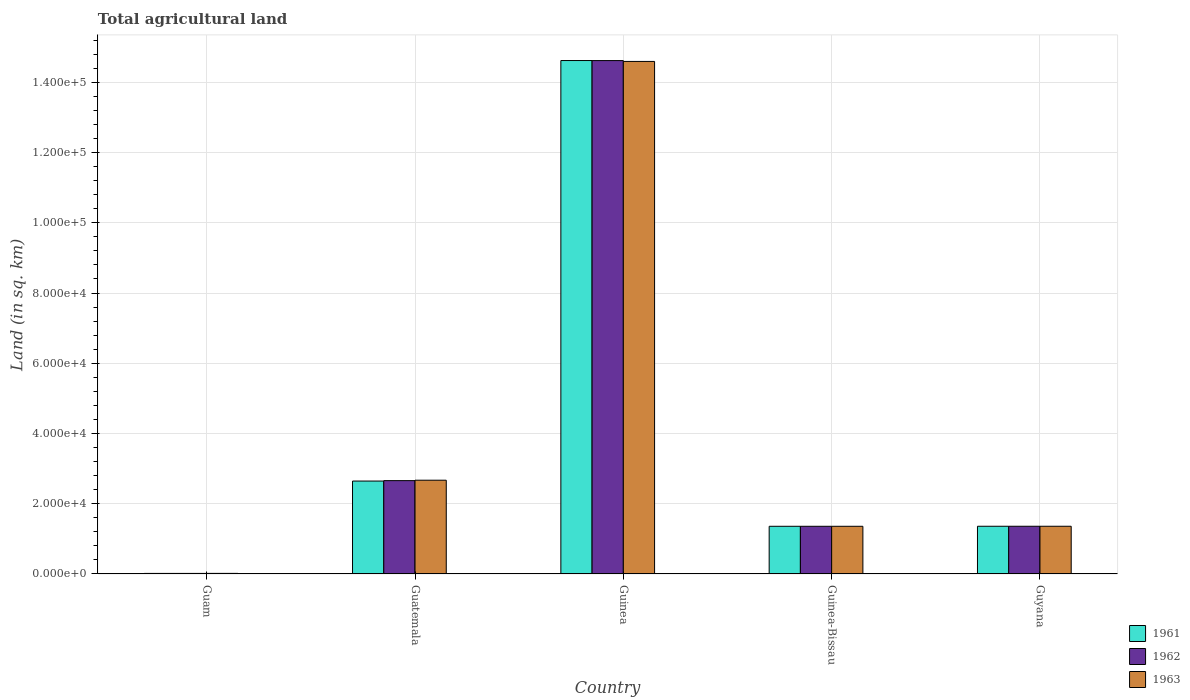Are the number of bars per tick equal to the number of legend labels?
Your response must be concise. Yes. How many bars are there on the 4th tick from the right?
Give a very brief answer. 3. What is the label of the 2nd group of bars from the left?
Make the answer very short. Guatemala. What is the total agricultural land in 1961 in Guinea-Bissau?
Your answer should be very brief. 1.36e+04. Across all countries, what is the maximum total agricultural land in 1962?
Make the answer very short. 1.46e+05. Across all countries, what is the minimum total agricultural land in 1963?
Keep it short and to the point. 170. In which country was the total agricultural land in 1962 maximum?
Your response must be concise. Guinea. In which country was the total agricultural land in 1961 minimum?
Make the answer very short. Guam. What is the total total agricultural land in 1962 in the graph?
Keep it short and to the point. 2.00e+05. What is the difference between the total agricultural land in 1962 in Guatemala and that in Guinea?
Give a very brief answer. -1.20e+05. What is the difference between the total agricultural land in 1961 in Guinea and the total agricultural land in 1963 in Guam?
Offer a terse response. 1.46e+05. What is the average total agricultural land in 1963 per country?
Ensure brevity in your answer.  4.00e+04. What is the difference between the total agricultural land of/in 1963 and total agricultural land of/in 1961 in Guyana?
Provide a short and direct response. 0. What is the ratio of the total agricultural land in 1962 in Guinea to that in Guyana?
Give a very brief answer. 10.76. Is the total agricultural land in 1963 in Guinea less than that in Guyana?
Offer a very short reply. No. Is the difference between the total agricultural land in 1963 in Guinea and Guyana greater than the difference between the total agricultural land in 1961 in Guinea and Guyana?
Your response must be concise. No. What is the difference between the highest and the second highest total agricultural land in 1963?
Offer a very short reply. -1.19e+05. What is the difference between the highest and the lowest total agricultural land in 1963?
Keep it short and to the point. 1.46e+05. Is the sum of the total agricultural land in 1961 in Guatemala and Guyana greater than the maximum total agricultural land in 1963 across all countries?
Your answer should be very brief. No. Is it the case that in every country, the sum of the total agricultural land in 1961 and total agricultural land in 1962 is greater than the total agricultural land in 1963?
Keep it short and to the point. Yes. How many bars are there?
Keep it short and to the point. 15. Does the graph contain grids?
Keep it short and to the point. Yes. How are the legend labels stacked?
Make the answer very short. Vertical. What is the title of the graph?
Your answer should be very brief. Total agricultural land. What is the label or title of the X-axis?
Keep it short and to the point. Country. What is the label or title of the Y-axis?
Your response must be concise. Land (in sq. km). What is the Land (in sq. km) of 1961 in Guam?
Keep it short and to the point. 160. What is the Land (in sq. km) of 1962 in Guam?
Give a very brief answer. 160. What is the Land (in sq. km) of 1963 in Guam?
Your answer should be very brief. 170. What is the Land (in sq. km) in 1961 in Guatemala?
Offer a very short reply. 2.65e+04. What is the Land (in sq. km) in 1962 in Guatemala?
Your answer should be compact. 2.66e+04. What is the Land (in sq. km) of 1963 in Guatemala?
Make the answer very short. 2.67e+04. What is the Land (in sq. km) in 1961 in Guinea?
Your answer should be compact. 1.46e+05. What is the Land (in sq. km) of 1962 in Guinea?
Provide a succinct answer. 1.46e+05. What is the Land (in sq. km) of 1963 in Guinea?
Offer a terse response. 1.46e+05. What is the Land (in sq. km) of 1961 in Guinea-Bissau?
Your answer should be compact. 1.36e+04. What is the Land (in sq. km) of 1962 in Guinea-Bissau?
Ensure brevity in your answer.  1.36e+04. What is the Land (in sq. km) of 1963 in Guinea-Bissau?
Keep it short and to the point. 1.36e+04. What is the Land (in sq. km) in 1961 in Guyana?
Give a very brief answer. 1.36e+04. What is the Land (in sq. km) in 1962 in Guyana?
Offer a terse response. 1.36e+04. What is the Land (in sq. km) in 1963 in Guyana?
Offer a very short reply. 1.36e+04. Across all countries, what is the maximum Land (in sq. km) in 1961?
Give a very brief answer. 1.46e+05. Across all countries, what is the maximum Land (in sq. km) of 1962?
Your answer should be compact. 1.46e+05. Across all countries, what is the maximum Land (in sq. km) in 1963?
Make the answer very short. 1.46e+05. Across all countries, what is the minimum Land (in sq. km) in 1961?
Offer a terse response. 160. Across all countries, what is the minimum Land (in sq. km) of 1962?
Keep it short and to the point. 160. Across all countries, what is the minimum Land (in sq. km) of 1963?
Offer a terse response. 170. What is the total Land (in sq. km) in 1961 in the graph?
Your answer should be compact. 2.00e+05. What is the total Land (in sq. km) of 1962 in the graph?
Give a very brief answer. 2.00e+05. What is the total Land (in sq. km) of 1963 in the graph?
Offer a very short reply. 2.00e+05. What is the difference between the Land (in sq. km) of 1961 in Guam and that in Guatemala?
Your response must be concise. -2.63e+04. What is the difference between the Land (in sq. km) in 1962 in Guam and that in Guatemala?
Ensure brevity in your answer.  -2.64e+04. What is the difference between the Land (in sq. km) in 1963 in Guam and that in Guatemala?
Keep it short and to the point. -2.65e+04. What is the difference between the Land (in sq. km) in 1961 in Guam and that in Guinea?
Keep it short and to the point. -1.46e+05. What is the difference between the Land (in sq. km) of 1962 in Guam and that in Guinea?
Make the answer very short. -1.46e+05. What is the difference between the Land (in sq. km) of 1963 in Guam and that in Guinea?
Provide a short and direct response. -1.46e+05. What is the difference between the Land (in sq. km) in 1961 in Guam and that in Guinea-Bissau?
Your answer should be compact. -1.34e+04. What is the difference between the Land (in sq. km) in 1962 in Guam and that in Guinea-Bissau?
Ensure brevity in your answer.  -1.34e+04. What is the difference between the Land (in sq. km) of 1963 in Guam and that in Guinea-Bissau?
Keep it short and to the point. -1.34e+04. What is the difference between the Land (in sq. km) in 1961 in Guam and that in Guyana?
Provide a succinct answer. -1.34e+04. What is the difference between the Land (in sq. km) of 1962 in Guam and that in Guyana?
Ensure brevity in your answer.  -1.34e+04. What is the difference between the Land (in sq. km) of 1963 in Guam and that in Guyana?
Offer a terse response. -1.34e+04. What is the difference between the Land (in sq. km) in 1961 in Guatemala and that in Guinea?
Offer a very short reply. -1.20e+05. What is the difference between the Land (in sq. km) in 1962 in Guatemala and that in Guinea?
Make the answer very short. -1.20e+05. What is the difference between the Land (in sq. km) in 1963 in Guatemala and that in Guinea?
Offer a very short reply. -1.19e+05. What is the difference between the Land (in sq. km) of 1961 in Guatemala and that in Guinea-Bissau?
Ensure brevity in your answer.  1.29e+04. What is the difference between the Land (in sq. km) in 1962 in Guatemala and that in Guinea-Bissau?
Your response must be concise. 1.30e+04. What is the difference between the Land (in sq. km) in 1963 in Guatemala and that in Guinea-Bissau?
Your answer should be compact. 1.31e+04. What is the difference between the Land (in sq. km) in 1961 in Guatemala and that in Guyana?
Make the answer very short. 1.29e+04. What is the difference between the Land (in sq. km) in 1962 in Guatemala and that in Guyana?
Your answer should be compact. 1.30e+04. What is the difference between the Land (in sq. km) in 1963 in Guatemala and that in Guyana?
Offer a terse response. 1.31e+04. What is the difference between the Land (in sq. km) of 1961 in Guinea and that in Guinea-Bissau?
Your answer should be very brief. 1.33e+05. What is the difference between the Land (in sq. km) of 1962 in Guinea and that in Guinea-Bissau?
Ensure brevity in your answer.  1.33e+05. What is the difference between the Land (in sq. km) in 1963 in Guinea and that in Guinea-Bissau?
Your response must be concise. 1.32e+05. What is the difference between the Land (in sq. km) of 1961 in Guinea and that in Guyana?
Ensure brevity in your answer.  1.33e+05. What is the difference between the Land (in sq. km) of 1962 in Guinea and that in Guyana?
Your answer should be compact. 1.33e+05. What is the difference between the Land (in sq. km) of 1963 in Guinea and that in Guyana?
Your response must be concise. 1.32e+05. What is the difference between the Land (in sq. km) in 1962 in Guinea-Bissau and that in Guyana?
Ensure brevity in your answer.  -10. What is the difference between the Land (in sq. km) in 1961 in Guam and the Land (in sq. km) in 1962 in Guatemala?
Ensure brevity in your answer.  -2.64e+04. What is the difference between the Land (in sq. km) in 1961 in Guam and the Land (in sq. km) in 1963 in Guatemala?
Offer a terse response. -2.65e+04. What is the difference between the Land (in sq. km) in 1962 in Guam and the Land (in sq. km) in 1963 in Guatemala?
Provide a short and direct response. -2.65e+04. What is the difference between the Land (in sq. km) of 1961 in Guam and the Land (in sq. km) of 1962 in Guinea?
Your answer should be very brief. -1.46e+05. What is the difference between the Land (in sq. km) in 1961 in Guam and the Land (in sq. km) in 1963 in Guinea?
Your response must be concise. -1.46e+05. What is the difference between the Land (in sq. km) in 1962 in Guam and the Land (in sq. km) in 1963 in Guinea?
Ensure brevity in your answer.  -1.46e+05. What is the difference between the Land (in sq. km) of 1961 in Guam and the Land (in sq. km) of 1962 in Guinea-Bissau?
Ensure brevity in your answer.  -1.34e+04. What is the difference between the Land (in sq. km) in 1961 in Guam and the Land (in sq. km) in 1963 in Guinea-Bissau?
Make the answer very short. -1.34e+04. What is the difference between the Land (in sq. km) in 1962 in Guam and the Land (in sq. km) in 1963 in Guinea-Bissau?
Provide a short and direct response. -1.34e+04. What is the difference between the Land (in sq. km) of 1961 in Guam and the Land (in sq. km) of 1962 in Guyana?
Your answer should be compact. -1.34e+04. What is the difference between the Land (in sq. km) in 1961 in Guam and the Land (in sq. km) in 1963 in Guyana?
Give a very brief answer. -1.34e+04. What is the difference between the Land (in sq. km) in 1962 in Guam and the Land (in sq. km) in 1963 in Guyana?
Your answer should be very brief. -1.34e+04. What is the difference between the Land (in sq. km) of 1961 in Guatemala and the Land (in sq. km) of 1962 in Guinea?
Offer a terse response. -1.20e+05. What is the difference between the Land (in sq. km) in 1961 in Guatemala and the Land (in sq. km) in 1963 in Guinea?
Offer a terse response. -1.19e+05. What is the difference between the Land (in sq. km) in 1962 in Guatemala and the Land (in sq. km) in 1963 in Guinea?
Offer a very short reply. -1.19e+05. What is the difference between the Land (in sq. km) in 1961 in Guatemala and the Land (in sq. km) in 1962 in Guinea-Bissau?
Give a very brief answer. 1.29e+04. What is the difference between the Land (in sq. km) in 1961 in Guatemala and the Land (in sq. km) in 1963 in Guinea-Bissau?
Give a very brief answer. 1.29e+04. What is the difference between the Land (in sq. km) of 1962 in Guatemala and the Land (in sq. km) of 1963 in Guinea-Bissau?
Offer a very short reply. 1.30e+04. What is the difference between the Land (in sq. km) of 1961 in Guatemala and the Land (in sq. km) of 1962 in Guyana?
Ensure brevity in your answer.  1.29e+04. What is the difference between the Land (in sq. km) of 1961 in Guatemala and the Land (in sq. km) of 1963 in Guyana?
Ensure brevity in your answer.  1.29e+04. What is the difference between the Land (in sq. km) in 1962 in Guatemala and the Land (in sq. km) in 1963 in Guyana?
Give a very brief answer. 1.30e+04. What is the difference between the Land (in sq. km) of 1961 in Guinea and the Land (in sq. km) of 1962 in Guinea-Bissau?
Provide a succinct answer. 1.33e+05. What is the difference between the Land (in sq. km) of 1961 in Guinea and the Land (in sq. km) of 1963 in Guinea-Bissau?
Provide a short and direct response. 1.33e+05. What is the difference between the Land (in sq. km) of 1962 in Guinea and the Land (in sq. km) of 1963 in Guinea-Bissau?
Provide a succinct answer. 1.33e+05. What is the difference between the Land (in sq. km) of 1961 in Guinea and the Land (in sq. km) of 1962 in Guyana?
Offer a very short reply. 1.33e+05. What is the difference between the Land (in sq. km) in 1961 in Guinea and the Land (in sq. km) in 1963 in Guyana?
Provide a short and direct response. 1.33e+05. What is the difference between the Land (in sq. km) of 1962 in Guinea and the Land (in sq. km) of 1963 in Guyana?
Your answer should be very brief. 1.33e+05. What is the difference between the Land (in sq. km) of 1961 in Guinea-Bissau and the Land (in sq. km) of 1962 in Guyana?
Ensure brevity in your answer.  -10. What is the difference between the Land (in sq. km) in 1961 in Guinea-Bissau and the Land (in sq. km) in 1963 in Guyana?
Your answer should be compact. -10. What is the average Land (in sq. km) of 1961 per country?
Your answer should be very brief. 4.00e+04. What is the average Land (in sq. km) in 1962 per country?
Your answer should be very brief. 4.00e+04. What is the average Land (in sq. km) in 1963 per country?
Offer a terse response. 4.00e+04. What is the difference between the Land (in sq. km) in 1961 and Land (in sq. km) in 1962 in Guam?
Keep it short and to the point. 0. What is the difference between the Land (in sq. km) in 1961 and Land (in sq. km) in 1963 in Guam?
Provide a succinct answer. -10. What is the difference between the Land (in sq. km) of 1962 and Land (in sq. km) of 1963 in Guam?
Provide a short and direct response. -10. What is the difference between the Land (in sq. km) of 1961 and Land (in sq. km) of 1962 in Guatemala?
Offer a terse response. -120. What is the difference between the Land (in sq. km) in 1961 and Land (in sq. km) in 1963 in Guatemala?
Your answer should be very brief. -240. What is the difference between the Land (in sq. km) in 1962 and Land (in sq. km) in 1963 in Guatemala?
Ensure brevity in your answer.  -120. What is the difference between the Land (in sq. km) in 1961 and Land (in sq. km) in 1962 in Guinea?
Offer a very short reply. 10. What is the difference between the Land (in sq. km) in 1961 and Land (in sq. km) in 1963 in Guinea?
Offer a very short reply. 250. What is the difference between the Land (in sq. km) in 1962 and Land (in sq. km) in 1963 in Guinea?
Give a very brief answer. 240. What is the difference between the Land (in sq. km) in 1961 and Land (in sq. km) in 1962 in Guyana?
Your response must be concise. 0. What is the difference between the Land (in sq. km) in 1961 and Land (in sq. km) in 1963 in Guyana?
Keep it short and to the point. 0. What is the ratio of the Land (in sq. km) in 1961 in Guam to that in Guatemala?
Your answer should be very brief. 0.01. What is the ratio of the Land (in sq. km) in 1962 in Guam to that in Guatemala?
Your response must be concise. 0.01. What is the ratio of the Land (in sq. km) of 1963 in Guam to that in Guatemala?
Your response must be concise. 0.01. What is the ratio of the Land (in sq. km) of 1961 in Guam to that in Guinea?
Provide a succinct answer. 0. What is the ratio of the Land (in sq. km) in 1962 in Guam to that in Guinea?
Offer a terse response. 0. What is the ratio of the Land (in sq. km) in 1963 in Guam to that in Guinea?
Provide a short and direct response. 0. What is the ratio of the Land (in sq. km) of 1961 in Guam to that in Guinea-Bissau?
Offer a very short reply. 0.01. What is the ratio of the Land (in sq. km) of 1962 in Guam to that in Guinea-Bissau?
Keep it short and to the point. 0.01. What is the ratio of the Land (in sq. km) of 1963 in Guam to that in Guinea-Bissau?
Keep it short and to the point. 0.01. What is the ratio of the Land (in sq. km) in 1961 in Guam to that in Guyana?
Offer a very short reply. 0.01. What is the ratio of the Land (in sq. km) in 1962 in Guam to that in Guyana?
Make the answer very short. 0.01. What is the ratio of the Land (in sq. km) of 1963 in Guam to that in Guyana?
Offer a very short reply. 0.01. What is the ratio of the Land (in sq. km) in 1961 in Guatemala to that in Guinea?
Your answer should be very brief. 0.18. What is the ratio of the Land (in sq. km) in 1962 in Guatemala to that in Guinea?
Your answer should be compact. 0.18. What is the ratio of the Land (in sq. km) in 1963 in Guatemala to that in Guinea?
Keep it short and to the point. 0.18. What is the ratio of the Land (in sq. km) of 1961 in Guatemala to that in Guinea-Bissau?
Your answer should be compact. 1.95. What is the ratio of the Land (in sq. km) of 1962 in Guatemala to that in Guinea-Bissau?
Offer a very short reply. 1.96. What is the ratio of the Land (in sq. km) of 1963 in Guatemala to that in Guinea-Bissau?
Your response must be concise. 1.97. What is the ratio of the Land (in sq. km) of 1961 in Guatemala to that in Guyana?
Keep it short and to the point. 1.95. What is the ratio of the Land (in sq. km) of 1962 in Guatemala to that in Guyana?
Give a very brief answer. 1.96. What is the ratio of the Land (in sq. km) in 1963 in Guatemala to that in Guyana?
Make the answer very short. 1.96. What is the ratio of the Land (in sq. km) of 1961 in Guinea to that in Guinea-Bissau?
Provide a succinct answer. 10.77. What is the ratio of the Land (in sq. km) of 1962 in Guinea to that in Guinea-Bissau?
Provide a succinct answer. 10.77. What is the ratio of the Land (in sq. km) in 1963 in Guinea to that in Guinea-Bissau?
Offer a very short reply. 10.75. What is the ratio of the Land (in sq. km) of 1961 in Guinea to that in Guyana?
Make the answer very short. 10.76. What is the ratio of the Land (in sq. km) of 1962 in Guinea to that in Guyana?
Give a very brief answer. 10.76. What is the ratio of the Land (in sq. km) in 1963 in Guinea to that in Guyana?
Offer a terse response. 10.74. What is the ratio of the Land (in sq. km) in 1961 in Guinea-Bissau to that in Guyana?
Ensure brevity in your answer.  1. What is the difference between the highest and the second highest Land (in sq. km) of 1961?
Offer a terse response. 1.20e+05. What is the difference between the highest and the second highest Land (in sq. km) of 1962?
Offer a very short reply. 1.20e+05. What is the difference between the highest and the second highest Land (in sq. km) in 1963?
Provide a succinct answer. 1.19e+05. What is the difference between the highest and the lowest Land (in sq. km) of 1961?
Give a very brief answer. 1.46e+05. What is the difference between the highest and the lowest Land (in sq. km) in 1962?
Provide a succinct answer. 1.46e+05. What is the difference between the highest and the lowest Land (in sq. km) in 1963?
Your answer should be very brief. 1.46e+05. 